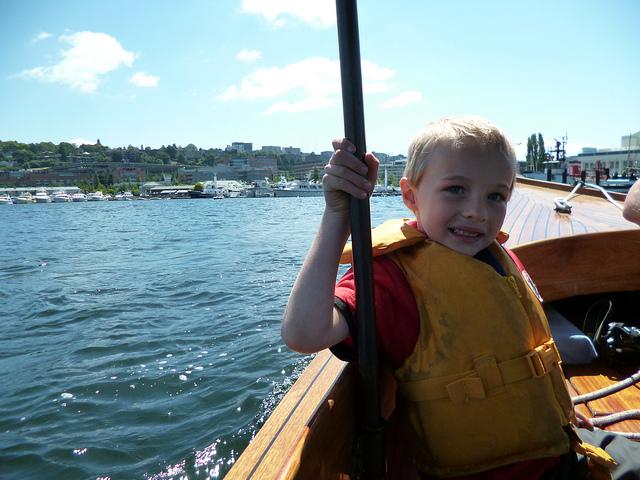From what material is the boat constructed?
Keep it brief. Wood. Is the child scared?
Be succinct. No. How cold is the water?
Write a very short answer. Not very. 